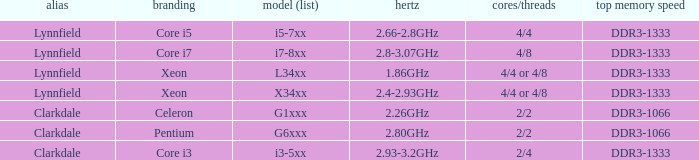List the number of cores for ddr3-1333 with frequencies between 2.66-2.8ghz. 4/4. 